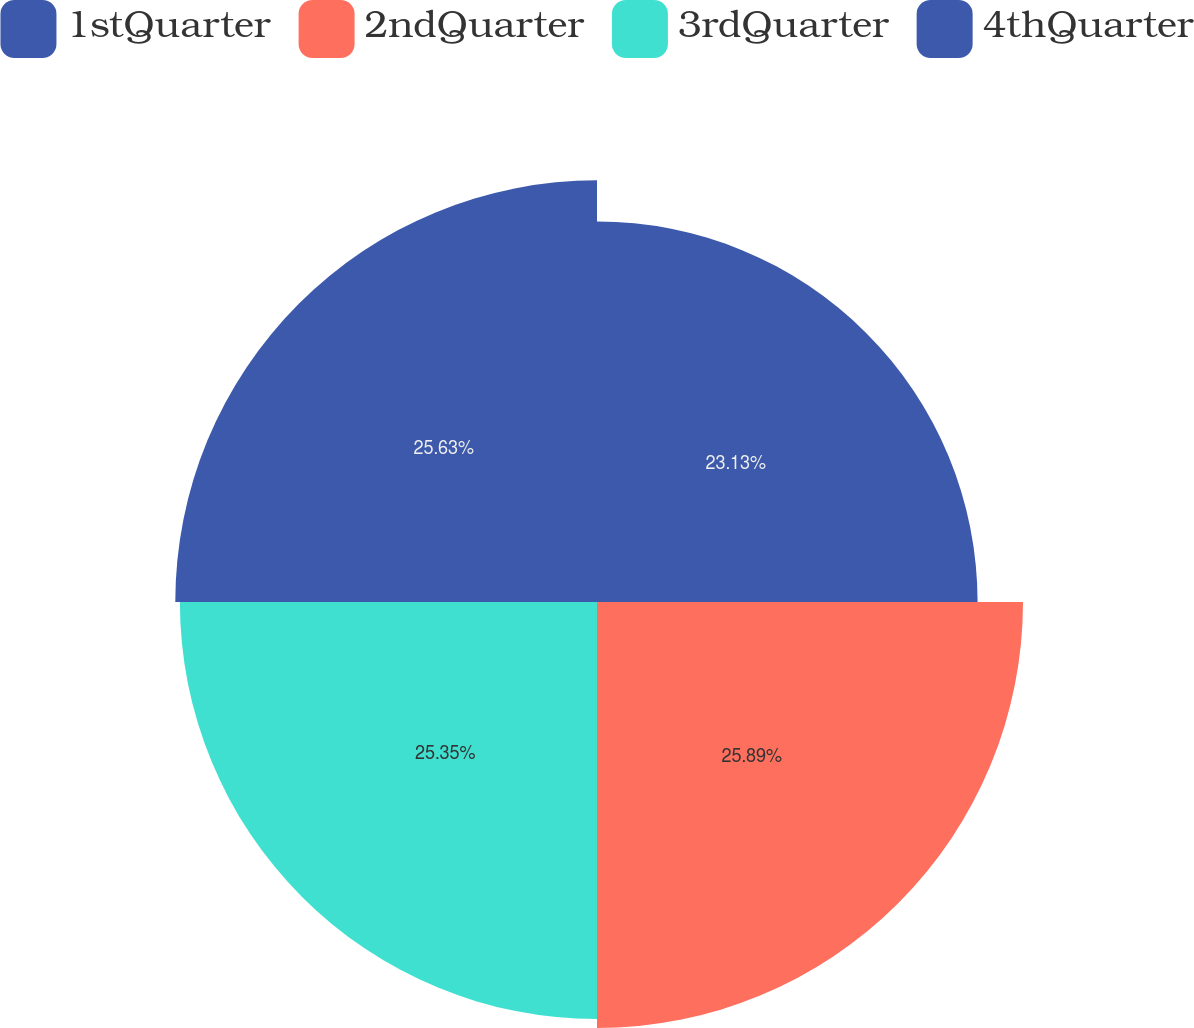Convert chart to OTSL. <chart><loc_0><loc_0><loc_500><loc_500><pie_chart><fcel>1stQuarter<fcel>2ndQuarter<fcel>3rdQuarter<fcel>4thQuarter<nl><fcel>23.13%<fcel>25.89%<fcel>25.35%<fcel>25.63%<nl></chart> 